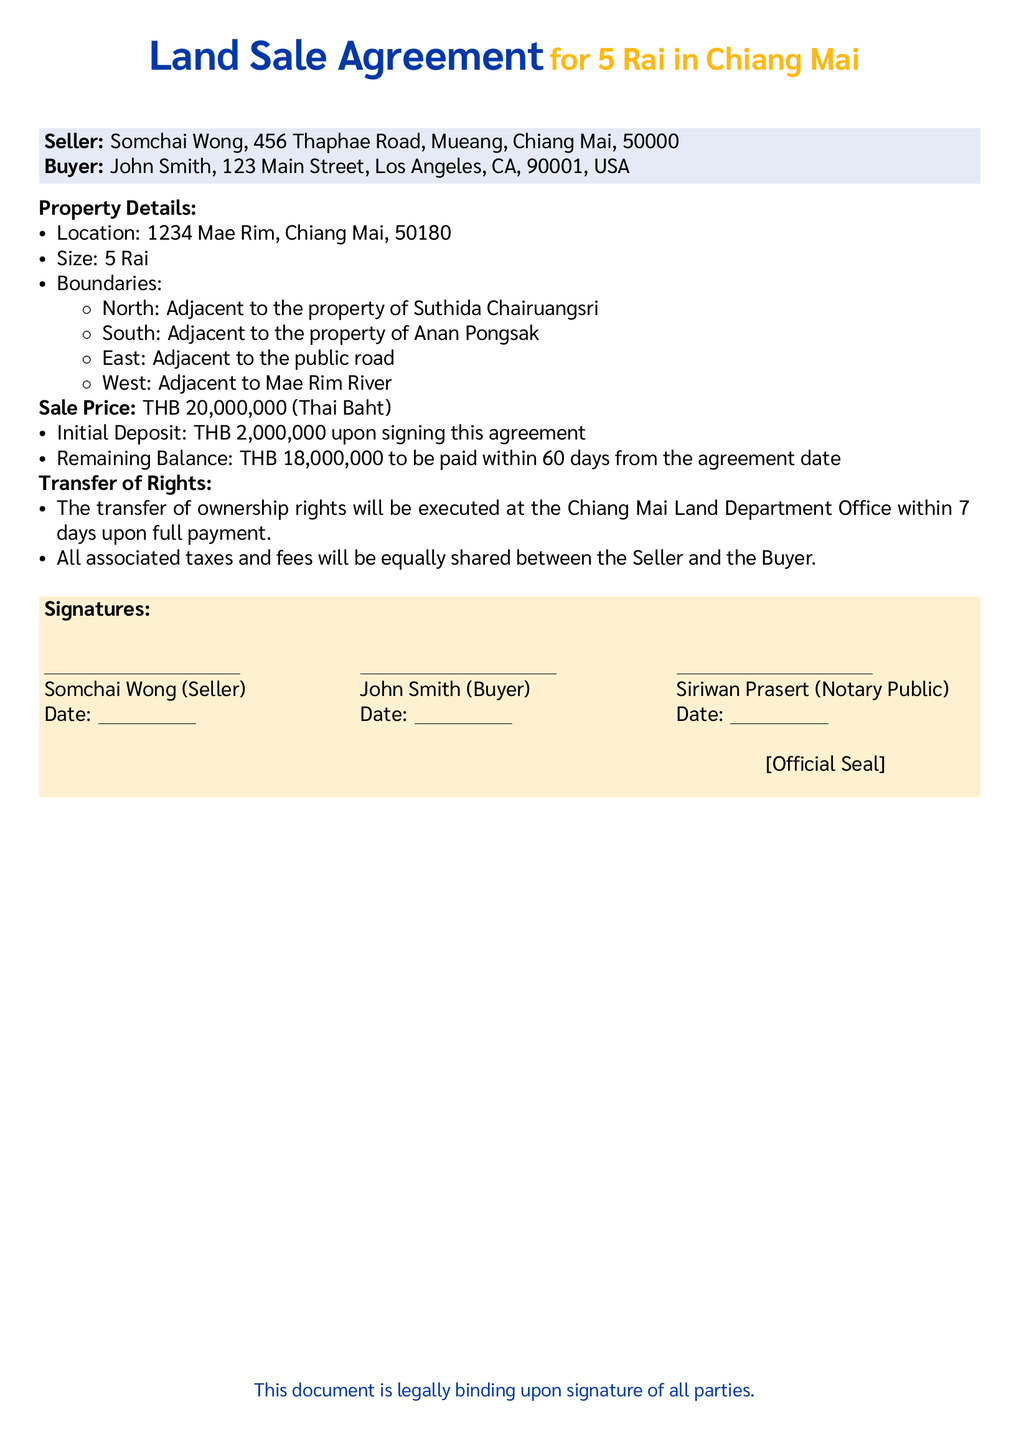What is the sale price of the property? The sale price is stated clearly in the document as the amount paid for the property.
Answer: THB 20,000,000 Who is the seller of the property? The seller's name and address are listed at the beginning of the document as the party providing the property.
Answer: Somchai Wong What is the size of the property? The document specifies the size of the property in Rai, which is a unit of land measurement in Thailand.
Answer: 5 Rai What is the initial deposit amount? The document outlines the payment terms, offering specifics on the deposit required from the buyer upon signing.
Answer: THB 2,000,000 What are the northern boundaries of the property? Boundaries of the property to the north are detailed in the document, identifying adjacent properties.
Answer: Adjacent to the property of Suthida Chairuangsri When is the transfer of ownership rights executed? The document specifies a time frame after full payment for the transfer of rights to occur officially.
Answer: Within 7 days Who is the notary public in this agreement? The document lists the notary public responsible for validating the signatures and the agreement.
Answer: Siriwan Prasert What is the remaining balance payment period? The document specifies how long the buyer has to pay the remainder of the sale price after the initial deposit.
Answer: 60 days Who shares associated taxes and fees? The document states how the costs related to the sale will be distributed between the two parties.
Answer: Equally shared between the Seller and the Buyer 